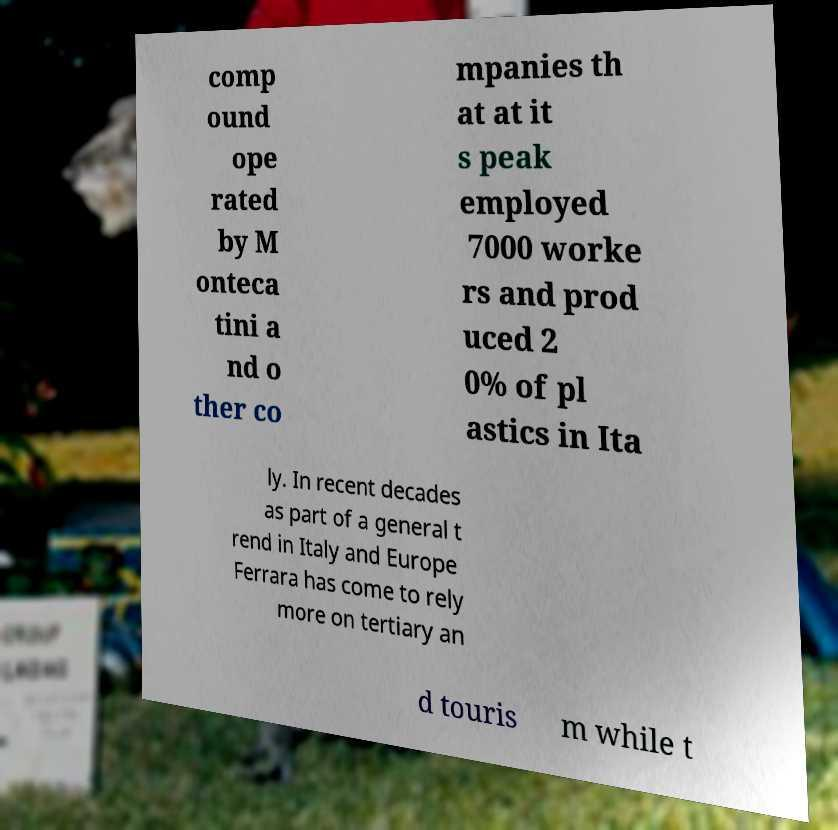What messages or text are displayed in this image? I need them in a readable, typed format. comp ound ope rated by M onteca tini a nd o ther co mpanies th at at it s peak employed 7000 worke rs and prod uced 2 0% of pl astics in Ita ly. In recent decades as part of a general t rend in Italy and Europe Ferrara has come to rely more on tertiary an d touris m while t 